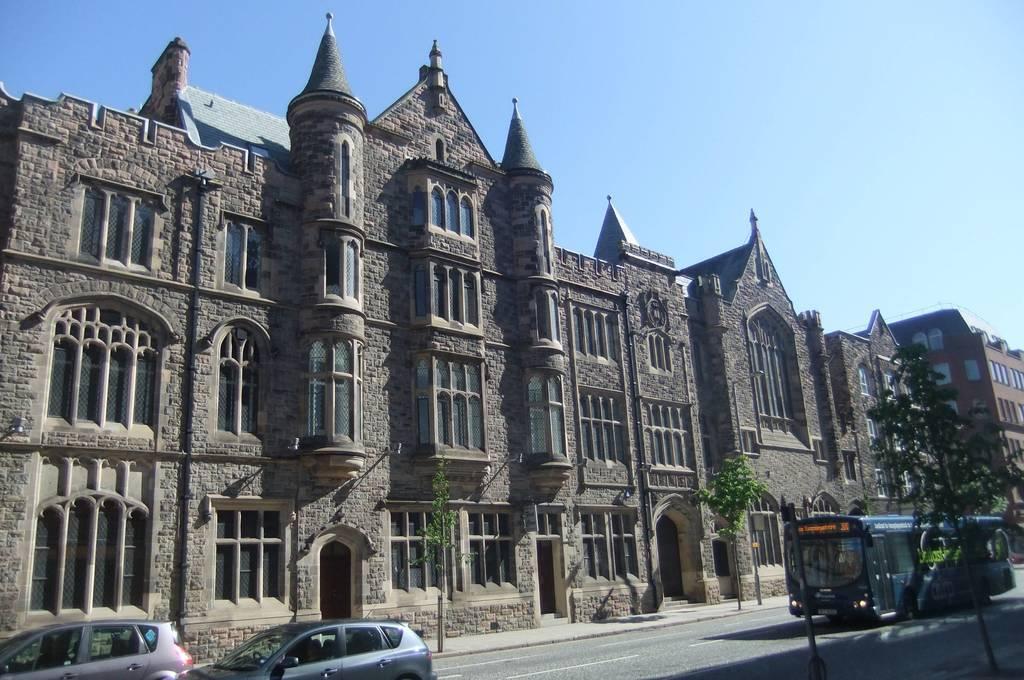Can you describe this image briefly? We can see bus and cars on the road and we can see trees,buildings,windows and sky. 